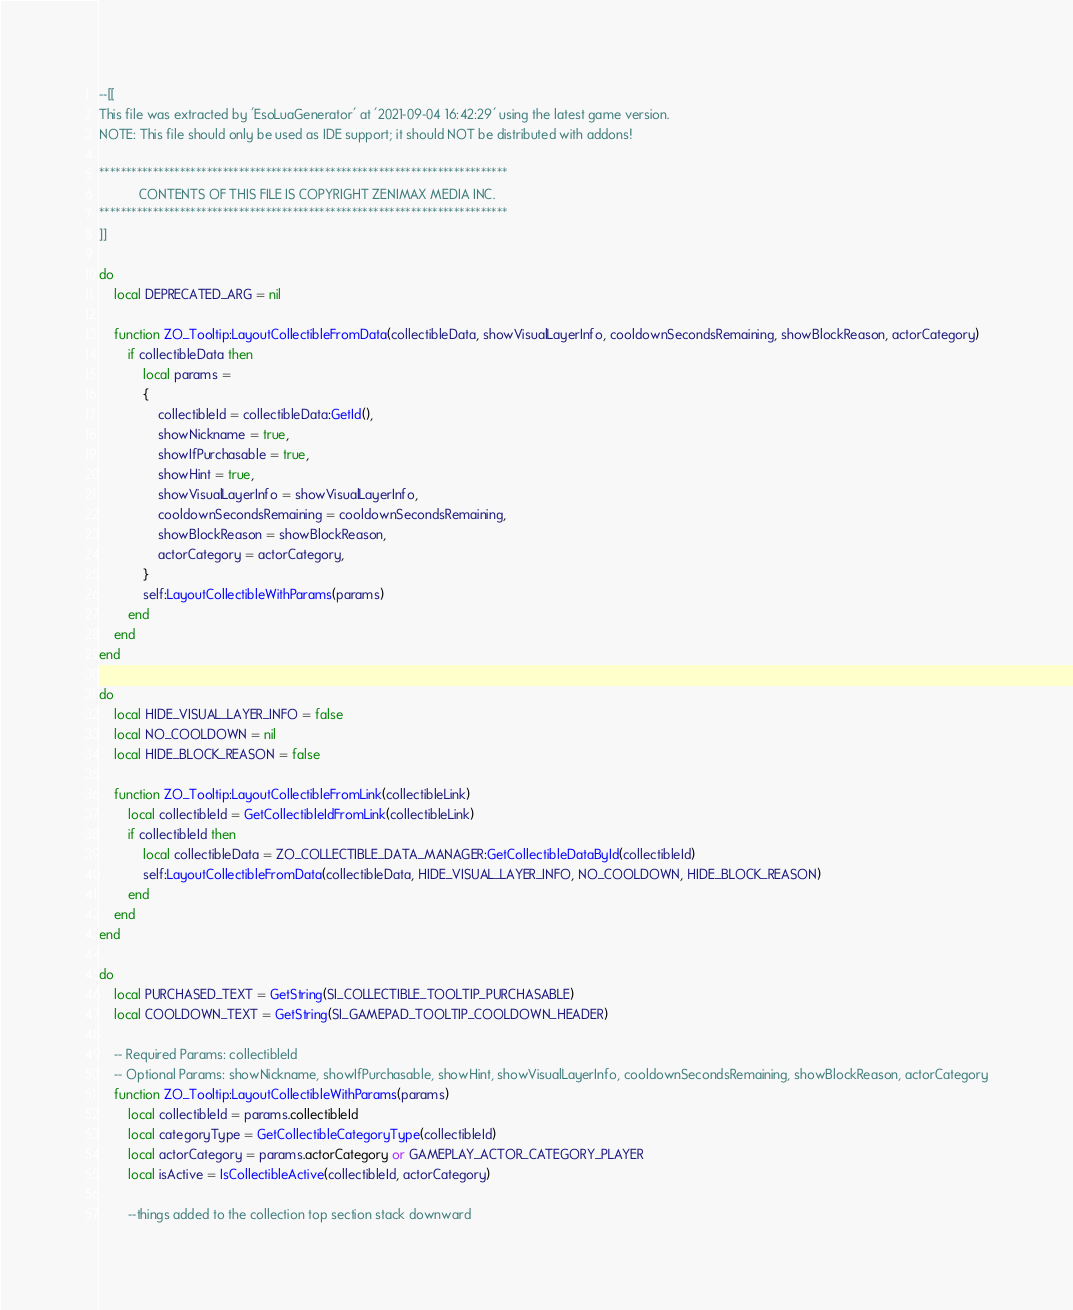Convert code to text. <code><loc_0><loc_0><loc_500><loc_500><_Lua_>--[[
This file was extracted by 'EsoLuaGenerator' at '2021-09-04 16:42:29' using the latest game version.
NOTE: This file should only be used as IDE support; it should NOT be distributed with addons!

****************************************************************************
           CONTENTS OF THIS FILE IS COPYRIGHT ZENIMAX MEDIA INC.
****************************************************************************
]]

do
    local DEPRECATED_ARG = nil

    function ZO_Tooltip:LayoutCollectibleFromData(collectibleData, showVisualLayerInfo, cooldownSecondsRemaining, showBlockReason, actorCategory)
        if collectibleData then
            local params =
            {
                collectibleId = collectibleData:GetId(),
                showNickname = true,
                showIfPurchasable = true,
                showHint = true,
                showVisualLayerInfo = showVisualLayerInfo,
                cooldownSecondsRemaining = cooldownSecondsRemaining,
                showBlockReason = showBlockReason,
                actorCategory = actorCategory,
            }
            self:LayoutCollectibleWithParams(params)
        end
    end
end

do
    local HIDE_VISUAL_LAYER_INFO = false
    local NO_COOLDOWN = nil
    local HIDE_BLOCK_REASON = false

    function ZO_Tooltip:LayoutCollectibleFromLink(collectibleLink)
        local collectibleId = GetCollectibleIdFromLink(collectibleLink)
        if collectibleId then
            local collectibleData = ZO_COLLECTIBLE_DATA_MANAGER:GetCollectibleDataById(collectibleId)
            self:LayoutCollectibleFromData(collectibleData, HIDE_VISUAL_LAYER_INFO, NO_COOLDOWN, HIDE_BLOCK_REASON)
        end
    end
end

do
    local PURCHASED_TEXT = GetString(SI_COLLECTIBLE_TOOLTIP_PURCHASABLE)
    local COOLDOWN_TEXT = GetString(SI_GAMEPAD_TOOLTIP_COOLDOWN_HEADER)

    -- Required Params: collectibleId
    -- Optional Params: showNickname, showIfPurchasable, showHint, showVisualLayerInfo, cooldownSecondsRemaining, showBlockReason, actorCategory
    function ZO_Tooltip:LayoutCollectibleWithParams(params)
        local collectibleId = params.collectibleId
        local categoryType = GetCollectibleCategoryType(collectibleId)
        local actorCategory = params.actorCategory or GAMEPLAY_ACTOR_CATEGORY_PLAYER
        local isActive = IsCollectibleActive(collectibleId, actorCategory)

        --things added to the collection top section stack downward</code> 